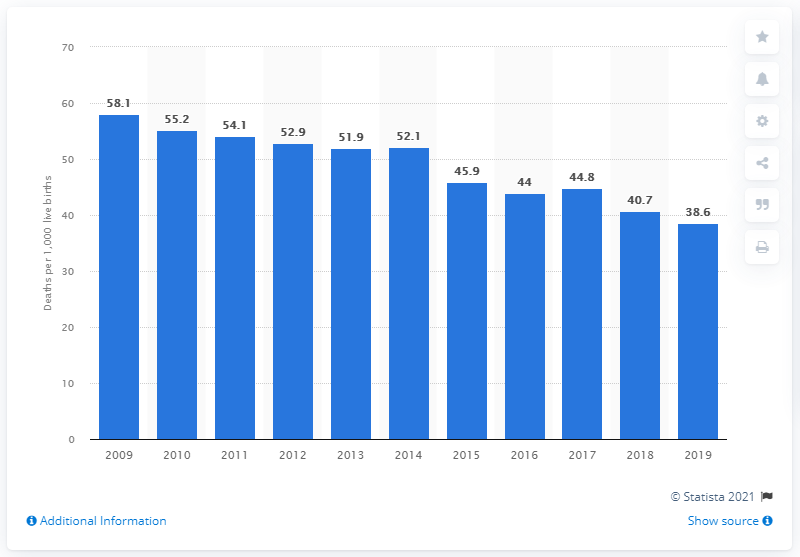List a handful of essential elements in this visual. The infant mortality rate in Swaziland in 2019 was 38.6 deaths per 1,000 live births, according to recent data. 